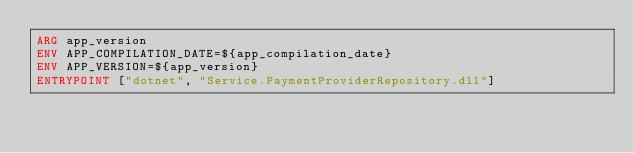<code> <loc_0><loc_0><loc_500><loc_500><_Dockerfile_>ARG app_version
ENV APP_COMPILATION_DATE=${app_compilation_date}
ENV APP_VERSION=${app_version}
ENTRYPOINT ["dotnet", "Service.PaymentProviderRepository.dll"]
</code> 